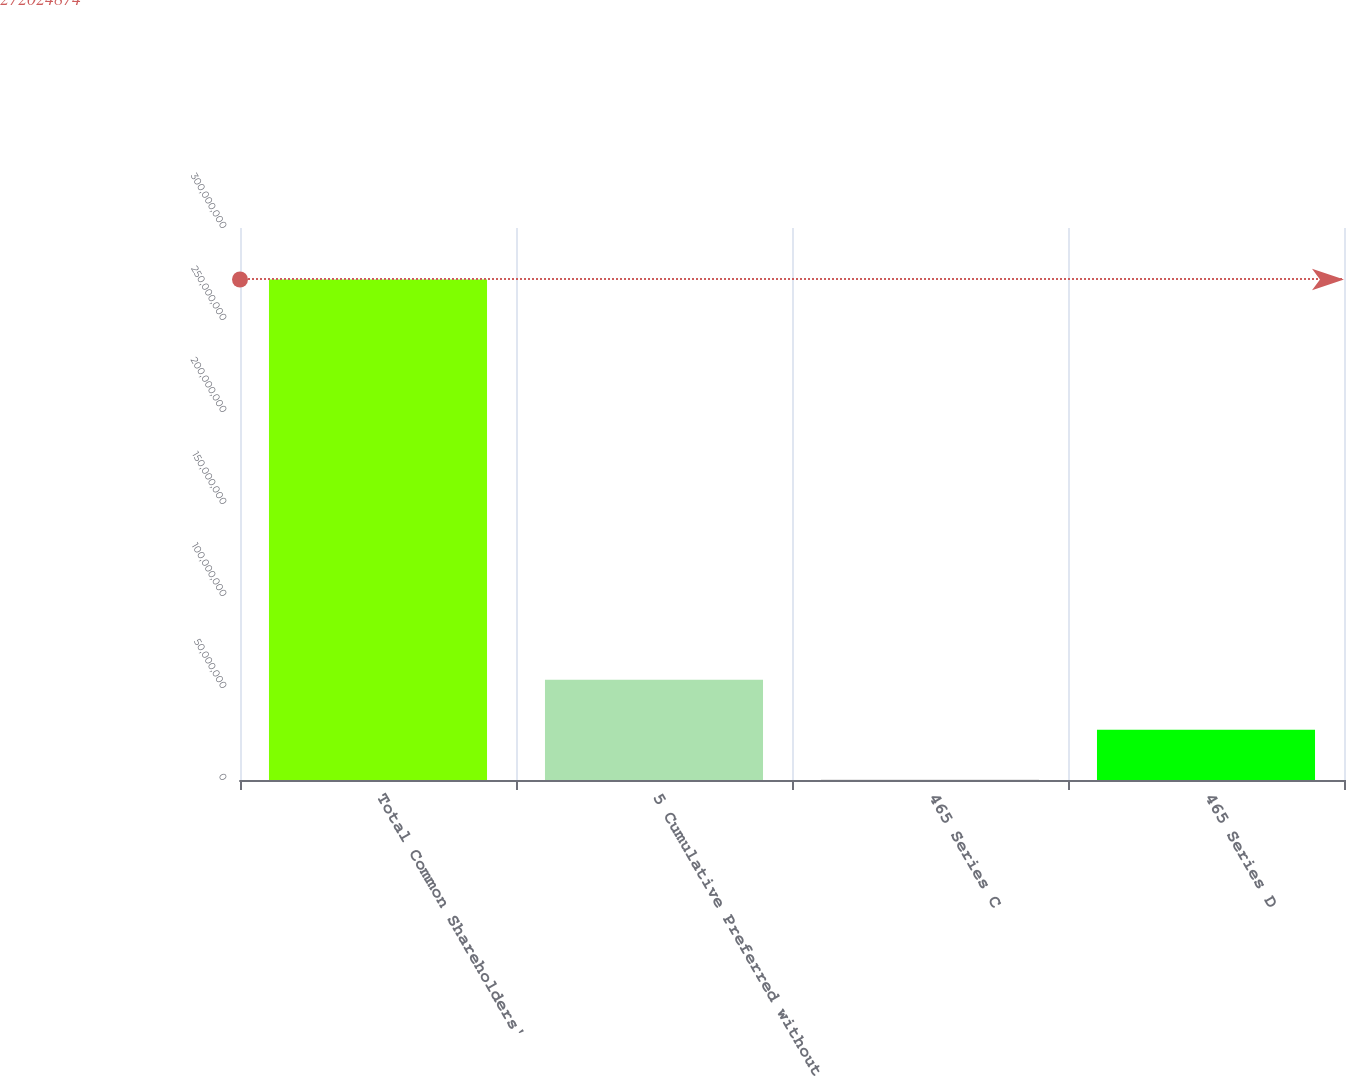<chart> <loc_0><loc_0><loc_500><loc_500><bar_chart><fcel>Total Common Shareholders'<fcel>5 Cumulative Preferred without<fcel>465 Series C<fcel>465 Series D<nl><fcel>2.72025e+08<fcel>5.45276e+07<fcel>153296<fcel>2.73405e+07<nl></chart> 